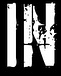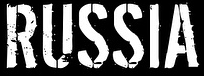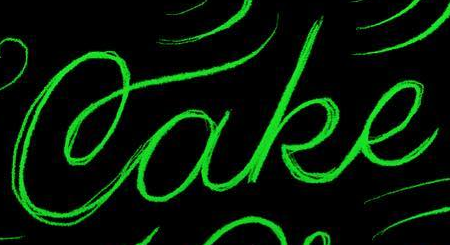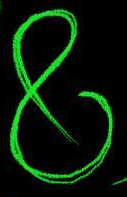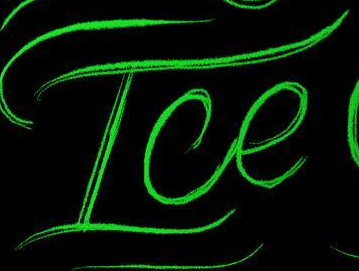Read the text from these images in sequence, separated by a semicolon. IN; RUSSIA; Cake; &; Ice 